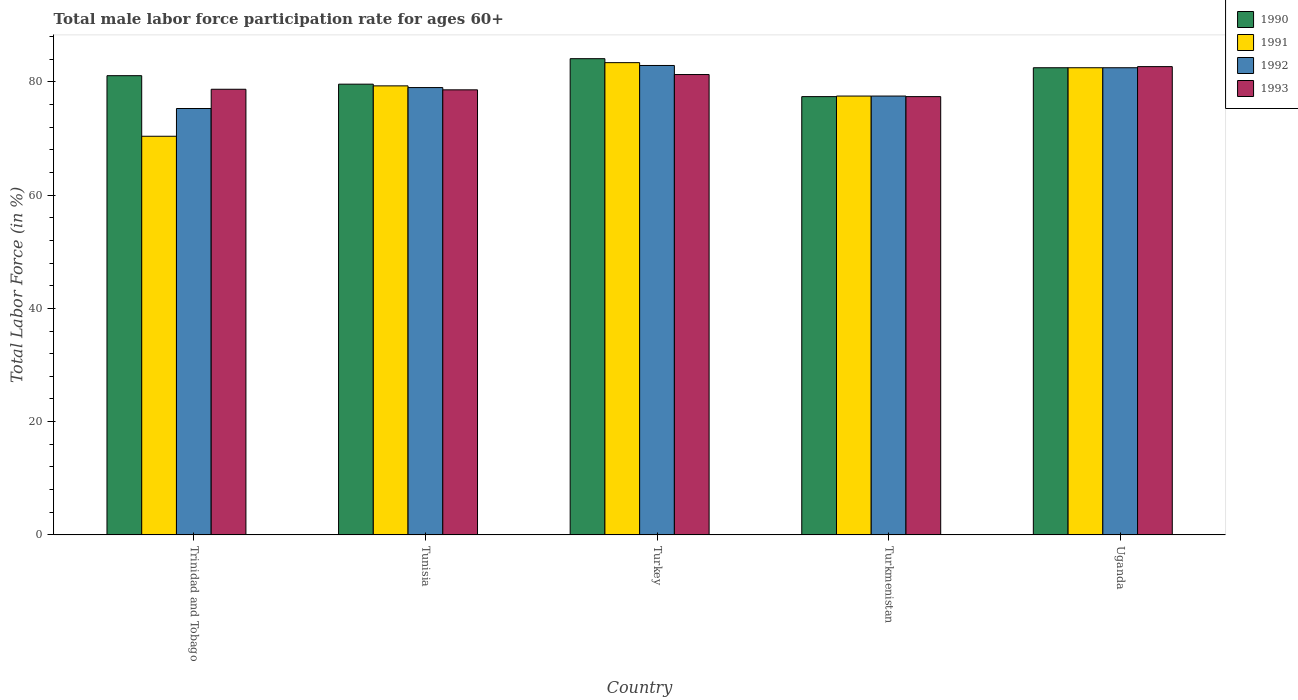How many groups of bars are there?
Your answer should be very brief. 5. Are the number of bars per tick equal to the number of legend labels?
Your answer should be very brief. Yes. What is the label of the 5th group of bars from the left?
Ensure brevity in your answer.  Uganda. In how many cases, is the number of bars for a given country not equal to the number of legend labels?
Your answer should be compact. 0. What is the male labor force participation rate in 1991 in Trinidad and Tobago?
Offer a very short reply. 70.4. Across all countries, what is the maximum male labor force participation rate in 1990?
Your answer should be very brief. 84.1. Across all countries, what is the minimum male labor force participation rate in 1992?
Ensure brevity in your answer.  75.3. In which country was the male labor force participation rate in 1992 maximum?
Offer a very short reply. Turkey. In which country was the male labor force participation rate in 1991 minimum?
Provide a short and direct response. Trinidad and Tobago. What is the total male labor force participation rate in 1991 in the graph?
Make the answer very short. 393.1. What is the difference between the male labor force participation rate in 1993 in Tunisia and that in Turkmenistan?
Your response must be concise. 1.2. What is the difference between the male labor force participation rate in 1992 in Turkmenistan and the male labor force participation rate in 1991 in Uganda?
Give a very brief answer. -5. What is the average male labor force participation rate in 1993 per country?
Make the answer very short. 79.74. What is the difference between the male labor force participation rate of/in 1991 and male labor force participation rate of/in 1990 in Turkey?
Your answer should be very brief. -0.7. What is the ratio of the male labor force participation rate in 1990 in Tunisia to that in Turkey?
Provide a short and direct response. 0.95. What is the difference between the highest and the second highest male labor force participation rate in 1993?
Ensure brevity in your answer.  -1.4. What is the difference between the highest and the lowest male labor force participation rate in 1992?
Offer a very short reply. 7.6. Is the sum of the male labor force participation rate in 1993 in Trinidad and Tobago and Turkey greater than the maximum male labor force participation rate in 1991 across all countries?
Keep it short and to the point. Yes. What does the 4th bar from the left in Trinidad and Tobago represents?
Offer a terse response. 1993. Is it the case that in every country, the sum of the male labor force participation rate in 1990 and male labor force participation rate in 1993 is greater than the male labor force participation rate in 1992?
Make the answer very short. Yes. Where does the legend appear in the graph?
Keep it short and to the point. Top right. What is the title of the graph?
Make the answer very short. Total male labor force participation rate for ages 60+. What is the label or title of the X-axis?
Provide a short and direct response. Country. What is the label or title of the Y-axis?
Make the answer very short. Total Labor Force (in %). What is the Total Labor Force (in %) in 1990 in Trinidad and Tobago?
Offer a very short reply. 81.1. What is the Total Labor Force (in %) of 1991 in Trinidad and Tobago?
Your answer should be compact. 70.4. What is the Total Labor Force (in %) of 1992 in Trinidad and Tobago?
Ensure brevity in your answer.  75.3. What is the Total Labor Force (in %) of 1993 in Trinidad and Tobago?
Your answer should be very brief. 78.7. What is the Total Labor Force (in %) of 1990 in Tunisia?
Give a very brief answer. 79.6. What is the Total Labor Force (in %) of 1991 in Tunisia?
Your answer should be compact. 79.3. What is the Total Labor Force (in %) of 1992 in Tunisia?
Ensure brevity in your answer.  79. What is the Total Labor Force (in %) in 1993 in Tunisia?
Your response must be concise. 78.6. What is the Total Labor Force (in %) of 1990 in Turkey?
Your answer should be very brief. 84.1. What is the Total Labor Force (in %) in 1991 in Turkey?
Your response must be concise. 83.4. What is the Total Labor Force (in %) in 1992 in Turkey?
Provide a succinct answer. 82.9. What is the Total Labor Force (in %) in 1993 in Turkey?
Offer a very short reply. 81.3. What is the Total Labor Force (in %) in 1990 in Turkmenistan?
Your answer should be compact. 77.4. What is the Total Labor Force (in %) in 1991 in Turkmenistan?
Make the answer very short. 77.5. What is the Total Labor Force (in %) of 1992 in Turkmenistan?
Your response must be concise. 77.5. What is the Total Labor Force (in %) of 1993 in Turkmenistan?
Provide a short and direct response. 77.4. What is the Total Labor Force (in %) in 1990 in Uganda?
Give a very brief answer. 82.5. What is the Total Labor Force (in %) of 1991 in Uganda?
Offer a very short reply. 82.5. What is the Total Labor Force (in %) in 1992 in Uganda?
Keep it short and to the point. 82.5. What is the Total Labor Force (in %) in 1993 in Uganda?
Provide a short and direct response. 82.7. Across all countries, what is the maximum Total Labor Force (in %) of 1990?
Your response must be concise. 84.1. Across all countries, what is the maximum Total Labor Force (in %) of 1991?
Keep it short and to the point. 83.4. Across all countries, what is the maximum Total Labor Force (in %) in 1992?
Make the answer very short. 82.9. Across all countries, what is the maximum Total Labor Force (in %) in 1993?
Your answer should be very brief. 82.7. Across all countries, what is the minimum Total Labor Force (in %) in 1990?
Provide a succinct answer. 77.4. Across all countries, what is the minimum Total Labor Force (in %) in 1991?
Give a very brief answer. 70.4. Across all countries, what is the minimum Total Labor Force (in %) of 1992?
Your answer should be very brief. 75.3. Across all countries, what is the minimum Total Labor Force (in %) of 1993?
Keep it short and to the point. 77.4. What is the total Total Labor Force (in %) of 1990 in the graph?
Your answer should be compact. 404.7. What is the total Total Labor Force (in %) in 1991 in the graph?
Provide a short and direct response. 393.1. What is the total Total Labor Force (in %) in 1992 in the graph?
Provide a succinct answer. 397.2. What is the total Total Labor Force (in %) of 1993 in the graph?
Offer a terse response. 398.7. What is the difference between the Total Labor Force (in %) in 1991 in Trinidad and Tobago and that in Tunisia?
Ensure brevity in your answer.  -8.9. What is the difference between the Total Labor Force (in %) of 1992 in Trinidad and Tobago and that in Tunisia?
Make the answer very short. -3.7. What is the difference between the Total Labor Force (in %) in 1991 in Trinidad and Tobago and that in Turkey?
Provide a succinct answer. -13. What is the difference between the Total Labor Force (in %) in 1993 in Trinidad and Tobago and that in Turkey?
Offer a terse response. -2.6. What is the difference between the Total Labor Force (in %) of 1993 in Trinidad and Tobago and that in Turkmenistan?
Provide a succinct answer. 1.3. What is the difference between the Total Labor Force (in %) in 1992 in Trinidad and Tobago and that in Uganda?
Offer a terse response. -7.2. What is the difference between the Total Labor Force (in %) of 1990 in Tunisia and that in Turkey?
Keep it short and to the point. -4.5. What is the difference between the Total Labor Force (in %) in 1992 in Tunisia and that in Turkey?
Provide a succinct answer. -3.9. What is the difference between the Total Labor Force (in %) of 1993 in Tunisia and that in Turkey?
Provide a succinct answer. -2.7. What is the difference between the Total Labor Force (in %) in 1990 in Tunisia and that in Turkmenistan?
Make the answer very short. 2.2. What is the difference between the Total Labor Force (in %) of 1991 in Tunisia and that in Turkmenistan?
Offer a terse response. 1.8. What is the difference between the Total Labor Force (in %) in 1992 in Tunisia and that in Turkmenistan?
Your response must be concise. 1.5. What is the difference between the Total Labor Force (in %) in 1992 in Tunisia and that in Uganda?
Provide a succinct answer. -3.5. What is the difference between the Total Labor Force (in %) in 1990 in Turkey and that in Turkmenistan?
Ensure brevity in your answer.  6.7. What is the difference between the Total Labor Force (in %) in 1992 in Turkey and that in Turkmenistan?
Make the answer very short. 5.4. What is the difference between the Total Labor Force (in %) of 1993 in Turkey and that in Turkmenistan?
Offer a terse response. 3.9. What is the difference between the Total Labor Force (in %) of 1990 in Turkey and that in Uganda?
Provide a short and direct response. 1.6. What is the difference between the Total Labor Force (in %) of 1990 in Turkmenistan and that in Uganda?
Give a very brief answer. -5.1. What is the difference between the Total Labor Force (in %) in 1991 in Turkmenistan and that in Uganda?
Your answer should be compact. -5. What is the difference between the Total Labor Force (in %) in 1992 in Trinidad and Tobago and the Total Labor Force (in %) in 1993 in Tunisia?
Give a very brief answer. -3.3. What is the difference between the Total Labor Force (in %) of 1990 in Trinidad and Tobago and the Total Labor Force (in %) of 1993 in Turkey?
Provide a succinct answer. -0.2. What is the difference between the Total Labor Force (in %) of 1992 in Trinidad and Tobago and the Total Labor Force (in %) of 1993 in Turkey?
Your answer should be compact. -6. What is the difference between the Total Labor Force (in %) of 1990 in Trinidad and Tobago and the Total Labor Force (in %) of 1991 in Turkmenistan?
Ensure brevity in your answer.  3.6. What is the difference between the Total Labor Force (in %) in 1990 in Trinidad and Tobago and the Total Labor Force (in %) in 1992 in Turkmenistan?
Provide a short and direct response. 3.6. What is the difference between the Total Labor Force (in %) of 1990 in Trinidad and Tobago and the Total Labor Force (in %) of 1993 in Turkmenistan?
Offer a very short reply. 3.7. What is the difference between the Total Labor Force (in %) in 1990 in Trinidad and Tobago and the Total Labor Force (in %) in 1991 in Uganda?
Your answer should be very brief. -1.4. What is the difference between the Total Labor Force (in %) in 1990 in Trinidad and Tobago and the Total Labor Force (in %) in 1993 in Uganda?
Make the answer very short. -1.6. What is the difference between the Total Labor Force (in %) in 1991 in Trinidad and Tobago and the Total Labor Force (in %) in 1993 in Uganda?
Give a very brief answer. -12.3. What is the difference between the Total Labor Force (in %) in 1992 in Trinidad and Tobago and the Total Labor Force (in %) in 1993 in Uganda?
Keep it short and to the point. -7.4. What is the difference between the Total Labor Force (in %) in 1990 in Tunisia and the Total Labor Force (in %) in 1992 in Turkey?
Give a very brief answer. -3.3. What is the difference between the Total Labor Force (in %) of 1991 in Tunisia and the Total Labor Force (in %) of 1993 in Turkey?
Offer a very short reply. -2. What is the difference between the Total Labor Force (in %) of 1990 in Tunisia and the Total Labor Force (in %) of 1992 in Turkmenistan?
Ensure brevity in your answer.  2.1. What is the difference between the Total Labor Force (in %) in 1990 in Tunisia and the Total Labor Force (in %) in 1993 in Turkmenistan?
Keep it short and to the point. 2.2. What is the difference between the Total Labor Force (in %) in 1991 in Tunisia and the Total Labor Force (in %) in 1992 in Turkmenistan?
Make the answer very short. 1.8. What is the difference between the Total Labor Force (in %) in 1990 in Tunisia and the Total Labor Force (in %) in 1992 in Uganda?
Make the answer very short. -2.9. What is the difference between the Total Labor Force (in %) of 1991 in Tunisia and the Total Labor Force (in %) of 1992 in Uganda?
Provide a succinct answer. -3.2. What is the difference between the Total Labor Force (in %) in 1990 in Turkey and the Total Labor Force (in %) in 1991 in Turkmenistan?
Provide a succinct answer. 6.6. What is the difference between the Total Labor Force (in %) of 1991 in Turkey and the Total Labor Force (in %) of 1992 in Turkmenistan?
Keep it short and to the point. 5.9. What is the difference between the Total Labor Force (in %) of 1991 in Turkey and the Total Labor Force (in %) of 1993 in Turkmenistan?
Offer a very short reply. 6. What is the difference between the Total Labor Force (in %) in 1992 in Turkey and the Total Labor Force (in %) in 1993 in Turkmenistan?
Give a very brief answer. 5.5. What is the difference between the Total Labor Force (in %) in 1990 in Turkey and the Total Labor Force (in %) in 1992 in Uganda?
Your answer should be compact. 1.6. What is the difference between the Total Labor Force (in %) in 1991 in Turkey and the Total Labor Force (in %) in 1992 in Uganda?
Offer a very short reply. 0.9. What is the difference between the Total Labor Force (in %) of 1992 in Turkey and the Total Labor Force (in %) of 1993 in Uganda?
Your answer should be very brief. 0.2. What is the difference between the Total Labor Force (in %) in 1990 in Turkmenistan and the Total Labor Force (in %) in 1993 in Uganda?
Offer a very short reply. -5.3. What is the average Total Labor Force (in %) in 1990 per country?
Make the answer very short. 80.94. What is the average Total Labor Force (in %) in 1991 per country?
Offer a very short reply. 78.62. What is the average Total Labor Force (in %) of 1992 per country?
Your response must be concise. 79.44. What is the average Total Labor Force (in %) of 1993 per country?
Your answer should be compact. 79.74. What is the difference between the Total Labor Force (in %) of 1990 and Total Labor Force (in %) of 1991 in Trinidad and Tobago?
Provide a succinct answer. 10.7. What is the difference between the Total Labor Force (in %) in 1990 and Total Labor Force (in %) in 1993 in Trinidad and Tobago?
Ensure brevity in your answer.  2.4. What is the difference between the Total Labor Force (in %) of 1991 and Total Labor Force (in %) of 1992 in Trinidad and Tobago?
Offer a terse response. -4.9. What is the difference between the Total Labor Force (in %) of 1992 and Total Labor Force (in %) of 1993 in Trinidad and Tobago?
Offer a terse response. -3.4. What is the difference between the Total Labor Force (in %) of 1991 and Total Labor Force (in %) of 1992 in Tunisia?
Provide a succinct answer. 0.3. What is the difference between the Total Labor Force (in %) of 1990 and Total Labor Force (in %) of 1991 in Turkey?
Offer a terse response. 0.7. What is the difference between the Total Labor Force (in %) in 1990 and Total Labor Force (in %) in 1992 in Turkey?
Your answer should be very brief. 1.2. What is the difference between the Total Labor Force (in %) of 1991 and Total Labor Force (in %) of 1993 in Turkey?
Give a very brief answer. 2.1. What is the difference between the Total Labor Force (in %) in 1990 and Total Labor Force (in %) in 1991 in Turkmenistan?
Provide a succinct answer. -0.1. What is the difference between the Total Labor Force (in %) of 1990 and Total Labor Force (in %) of 1993 in Turkmenistan?
Your answer should be very brief. 0. What is the difference between the Total Labor Force (in %) in 1991 and Total Labor Force (in %) in 1993 in Turkmenistan?
Your response must be concise. 0.1. What is the difference between the Total Labor Force (in %) of 1990 and Total Labor Force (in %) of 1991 in Uganda?
Ensure brevity in your answer.  0. What is the difference between the Total Labor Force (in %) in 1990 and Total Labor Force (in %) in 1992 in Uganda?
Ensure brevity in your answer.  0. What is the ratio of the Total Labor Force (in %) in 1990 in Trinidad and Tobago to that in Tunisia?
Provide a short and direct response. 1.02. What is the ratio of the Total Labor Force (in %) of 1991 in Trinidad and Tobago to that in Tunisia?
Give a very brief answer. 0.89. What is the ratio of the Total Labor Force (in %) of 1992 in Trinidad and Tobago to that in Tunisia?
Give a very brief answer. 0.95. What is the ratio of the Total Labor Force (in %) of 1993 in Trinidad and Tobago to that in Tunisia?
Your answer should be compact. 1. What is the ratio of the Total Labor Force (in %) of 1991 in Trinidad and Tobago to that in Turkey?
Make the answer very short. 0.84. What is the ratio of the Total Labor Force (in %) in 1992 in Trinidad and Tobago to that in Turkey?
Keep it short and to the point. 0.91. What is the ratio of the Total Labor Force (in %) of 1990 in Trinidad and Tobago to that in Turkmenistan?
Keep it short and to the point. 1.05. What is the ratio of the Total Labor Force (in %) of 1991 in Trinidad and Tobago to that in Turkmenistan?
Your response must be concise. 0.91. What is the ratio of the Total Labor Force (in %) of 1992 in Trinidad and Tobago to that in Turkmenistan?
Offer a very short reply. 0.97. What is the ratio of the Total Labor Force (in %) of 1993 in Trinidad and Tobago to that in Turkmenistan?
Provide a short and direct response. 1.02. What is the ratio of the Total Labor Force (in %) of 1991 in Trinidad and Tobago to that in Uganda?
Your answer should be very brief. 0.85. What is the ratio of the Total Labor Force (in %) of 1992 in Trinidad and Tobago to that in Uganda?
Make the answer very short. 0.91. What is the ratio of the Total Labor Force (in %) of 1993 in Trinidad and Tobago to that in Uganda?
Your response must be concise. 0.95. What is the ratio of the Total Labor Force (in %) in 1990 in Tunisia to that in Turkey?
Offer a terse response. 0.95. What is the ratio of the Total Labor Force (in %) of 1991 in Tunisia to that in Turkey?
Your answer should be compact. 0.95. What is the ratio of the Total Labor Force (in %) in 1992 in Tunisia to that in Turkey?
Ensure brevity in your answer.  0.95. What is the ratio of the Total Labor Force (in %) in 1993 in Tunisia to that in Turkey?
Make the answer very short. 0.97. What is the ratio of the Total Labor Force (in %) in 1990 in Tunisia to that in Turkmenistan?
Offer a terse response. 1.03. What is the ratio of the Total Labor Force (in %) in 1991 in Tunisia to that in Turkmenistan?
Offer a very short reply. 1.02. What is the ratio of the Total Labor Force (in %) of 1992 in Tunisia to that in Turkmenistan?
Offer a terse response. 1.02. What is the ratio of the Total Labor Force (in %) of 1993 in Tunisia to that in Turkmenistan?
Provide a short and direct response. 1.02. What is the ratio of the Total Labor Force (in %) in 1990 in Tunisia to that in Uganda?
Your answer should be very brief. 0.96. What is the ratio of the Total Labor Force (in %) in 1991 in Tunisia to that in Uganda?
Keep it short and to the point. 0.96. What is the ratio of the Total Labor Force (in %) of 1992 in Tunisia to that in Uganda?
Offer a terse response. 0.96. What is the ratio of the Total Labor Force (in %) in 1993 in Tunisia to that in Uganda?
Offer a very short reply. 0.95. What is the ratio of the Total Labor Force (in %) of 1990 in Turkey to that in Turkmenistan?
Keep it short and to the point. 1.09. What is the ratio of the Total Labor Force (in %) of 1991 in Turkey to that in Turkmenistan?
Your answer should be very brief. 1.08. What is the ratio of the Total Labor Force (in %) of 1992 in Turkey to that in Turkmenistan?
Offer a very short reply. 1.07. What is the ratio of the Total Labor Force (in %) of 1993 in Turkey to that in Turkmenistan?
Keep it short and to the point. 1.05. What is the ratio of the Total Labor Force (in %) in 1990 in Turkey to that in Uganda?
Offer a very short reply. 1.02. What is the ratio of the Total Labor Force (in %) in 1991 in Turkey to that in Uganda?
Provide a succinct answer. 1.01. What is the ratio of the Total Labor Force (in %) in 1993 in Turkey to that in Uganda?
Make the answer very short. 0.98. What is the ratio of the Total Labor Force (in %) in 1990 in Turkmenistan to that in Uganda?
Your answer should be compact. 0.94. What is the ratio of the Total Labor Force (in %) of 1991 in Turkmenistan to that in Uganda?
Keep it short and to the point. 0.94. What is the ratio of the Total Labor Force (in %) in 1992 in Turkmenistan to that in Uganda?
Provide a short and direct response. 0.94. What is the ratio of the Total Labor Force (in %) of 1993 in Turkmenistan to that in Uganda?
Give a very brief answer. 0.94. What is the difference between the highest and the second highest Total Labor Force (in %) of 1990?
Your response must be concise. 1.6. What is the difference between the highest and the second highest Total Labor Force (in %) of 1991?
Your answer should be compact. 0.9. What is the difference between the highest and the second highest Total Labor Force (in %) in 1993?
Your answer should be very brief. 1.4. What is the difference between the highest and the lowest Total Labor Force (in %) of 1991?
Provide a short and direct response. 13. What is the difference between the highest and the lowest Total Labor Force (in %) of 1992?
Keep it short and to the point. 7.6. What is the difference between the highest and the lowest Total Labor Force (in %) in 1993?
Your response must be concise. 5.3. 